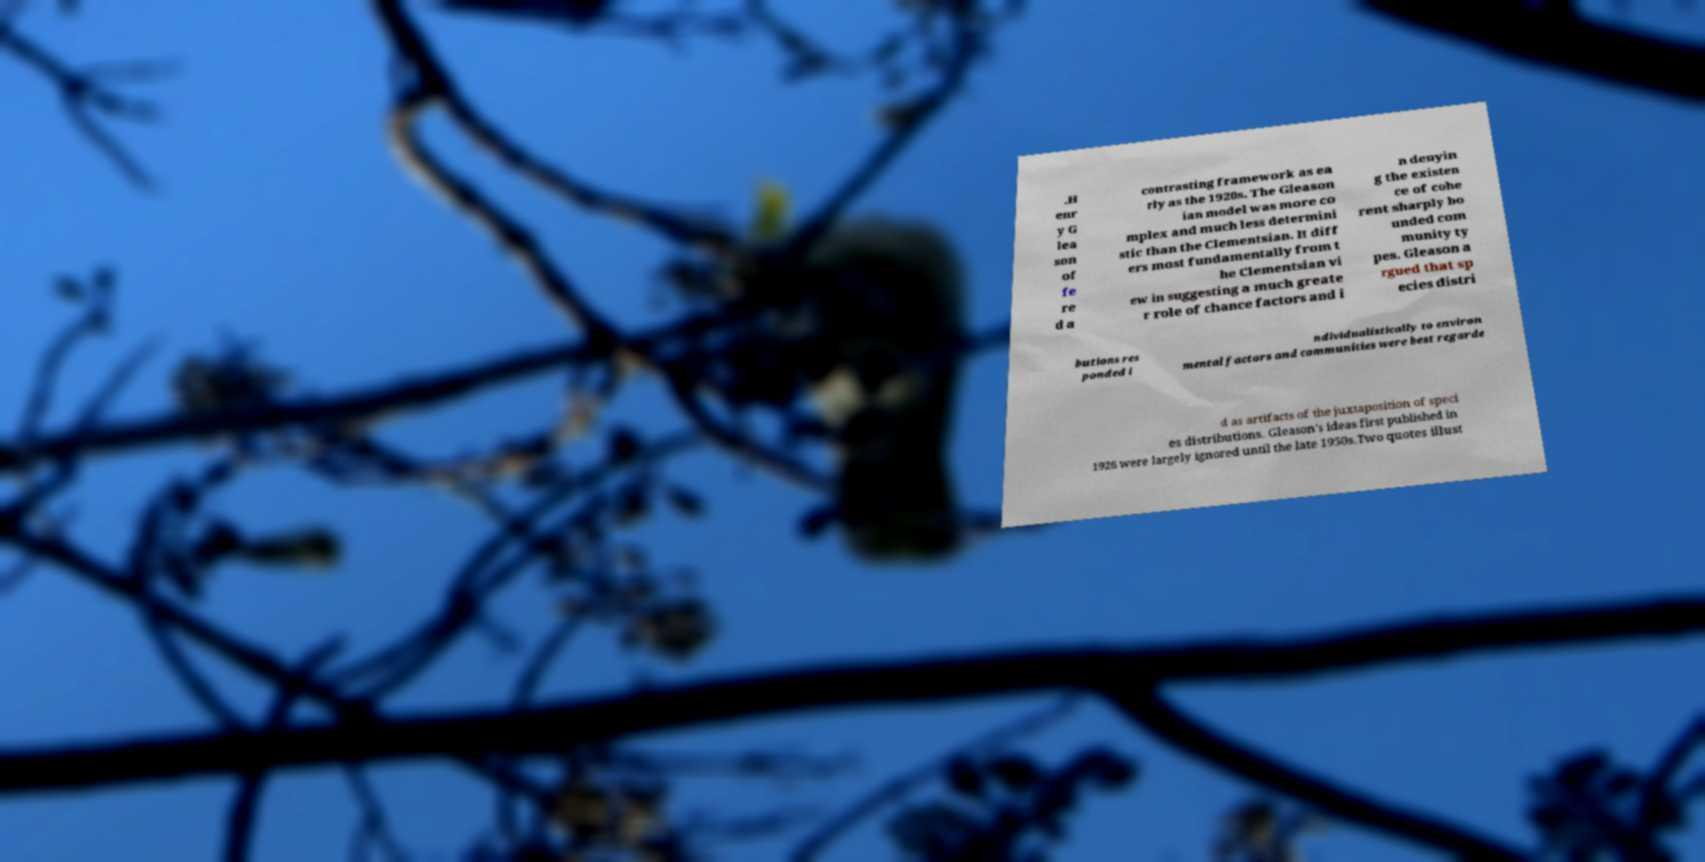Please read and relay the text visible in this image. What does it say? .H enr y G lea son of fe re d a contrasting framework as ea rly as the 1920s. The Gleason ian model was more co mplex and much less determini stic than the Clementsian. It diff ers most fundamentally from t he Clementsian vi ew in suggesting a much greate r role of chance factors and i n denyin g the existen ce of cohe rent sharply bo unded com munity ty pes. Gleason a rgued that sp ecies distri butions res ponded i ndividualistically to environ mental factors and communities were best regarde d as artifacts of the juxtaposition of speci es distributions. Gleason's ideas first published in 1926 were largely ignored until the late 1950s.Two quotes illust 